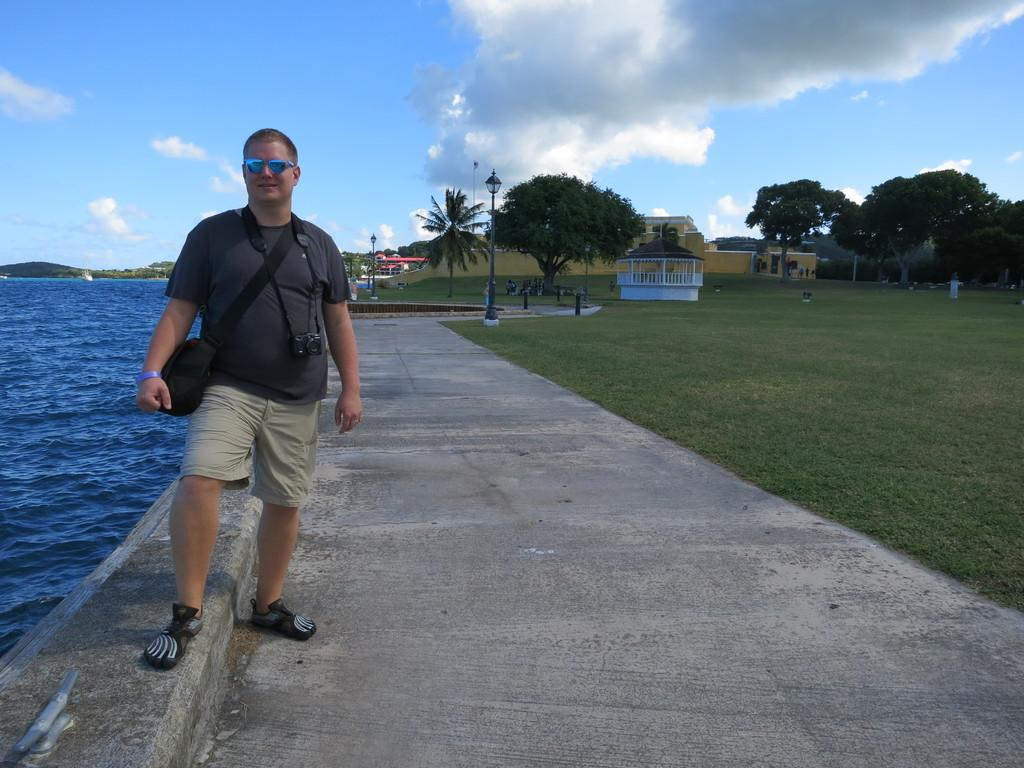What type of structures can be seen in the image? There are buildings in the image. What natural elements are present in the image? There are trees and grass on the ground in the image. What can be seen illuminating the scene in the image? There are lights visible in the image. What is the man in the image wearing? The man is wearing a bag and a camera in the image. What is the weather like in the image? The sky is blue and cloudy in the image. What is visible on the side of the image? Water is visible on the side of the image. What type of bed can be seen in the image? There is no bed present in the image. How does the acoustics of the scene affect the man's photography in the image? There is no information about the acoustics of the scene or its effect on the man's photography in the image. 